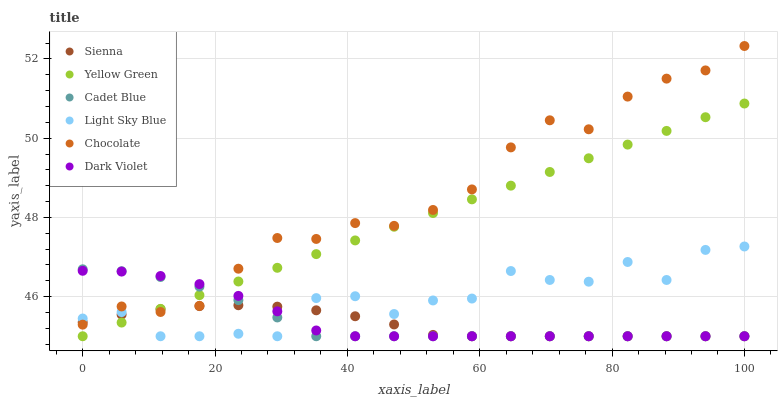Does Sienna have the minimum area under the curve?
Answer yes or no. Yes. Does Chocolate have the maximum area under the curve?
Answer yes or no. Yes. Does Yellow Green have the minimum area under the curve?
Answer yes or no. No. Does Yellow Green have the maximum area under the curve?
Answer yes or no. No. Is Yellow Green the smoothest?
Answer yes or no. Yes. Is Light Sky Blue the roughest?
Answer yes or no. Yes. Is Dark Violet the smoothest?
Answer yes or no. No. Is Dark Violet the roughest?
Answer yes or no. No. Does Cadet Blue have the lowest value?
Answer yes or no. Yes. Does Chocolate have the lowest value?
Answer yes or no. No. Does Chocolate have the highest value?
Answer yes or no. Yes. Does Yellow Green have the highest value?
Answer yes or no. No. Does Yellow Green intersect Chocolate?
Answer yes or no. Yes. Is Yellow Green less than Chocolate?
Answer yes or no. No. Is Yellow Green greater than Chocolate?
Answer yes or no. No. 